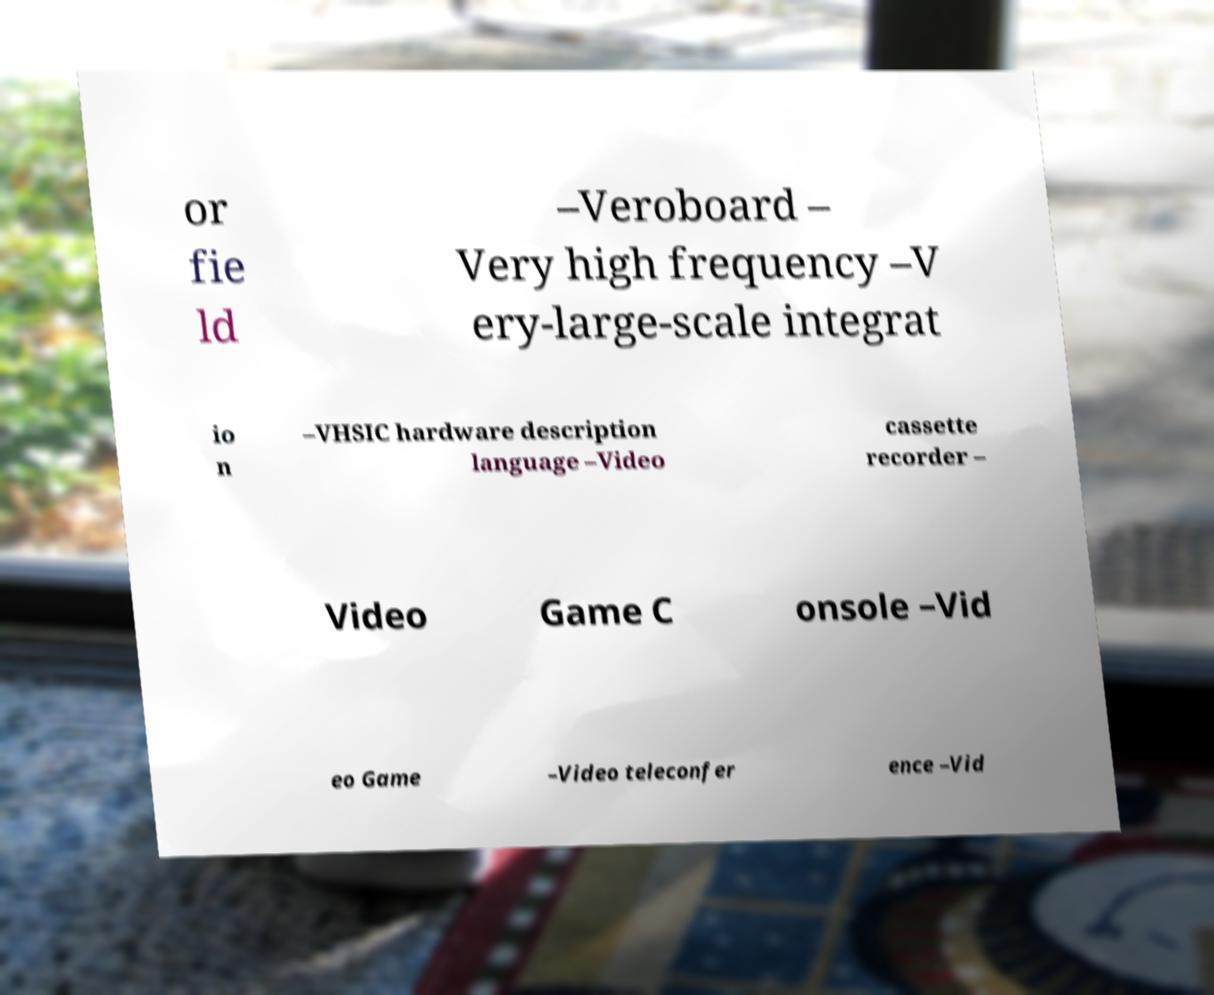I need the written content from this picture converted into text. Can you do that? or fie ld –Veroboard – Very high frequency –V ery-large-scale integrat io n –VHSIC hardware description language –Video cassette recorder – Video Game C onsole –Vid eo Game –Video teleconfer ence –Vid 